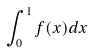<formula> <loc_0><loc_0><loc_500><loc_500>\int _ { 0 } ^ { 1 } f ( x ) d x</formula> 